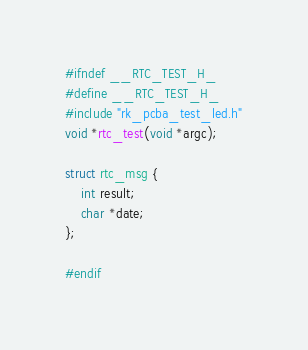Convert code to text. <code><loc_0><loc_0><loc_500><loc_500><_C_>#ifndef __RTC_TEST_H_
#define __RTC_TEST_H_
#include "rk_pcba_test_led.h"
void *rtc_test(void *argc);

struct rtc_msg {
	int result;
	char *date;
};

#endif

</code> 